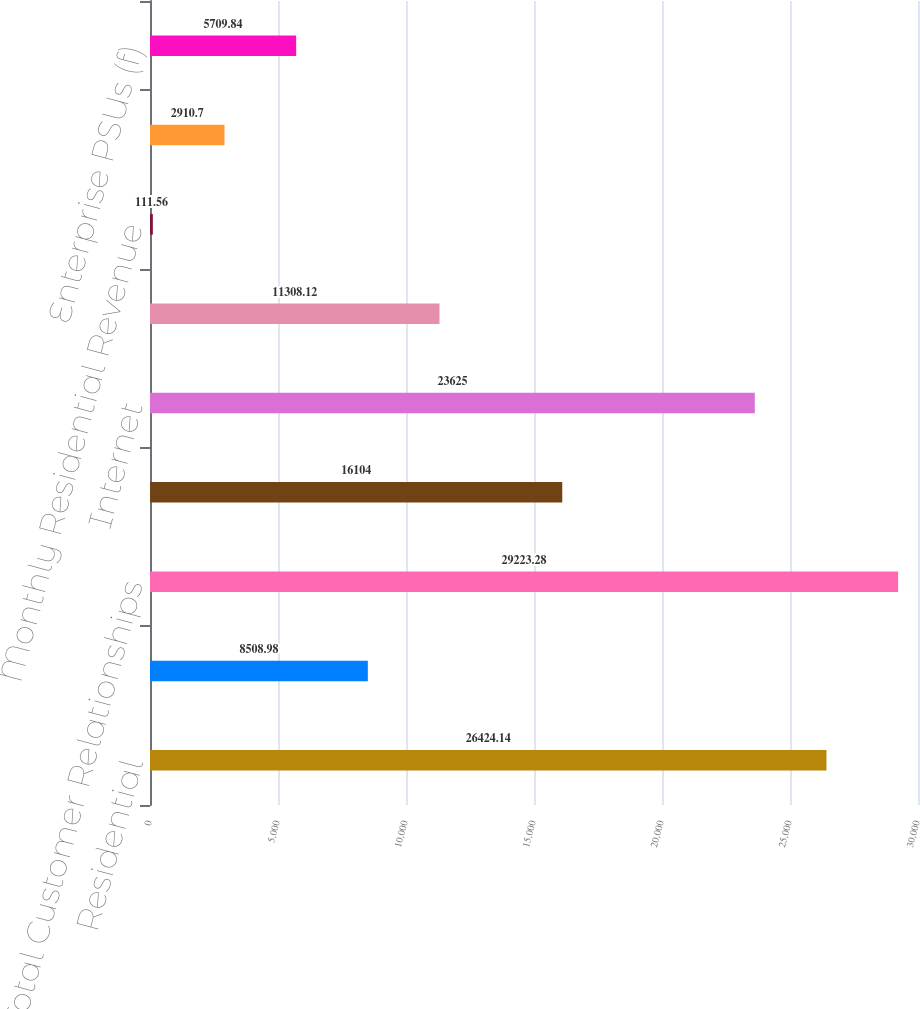Convert chart to OTSL. <chart><loc_0><loc_0><loc_500><loc_500><bar_chart><fcel>Residential<fcel>Small and Medium Business<fcel>Total Customer Relationships<fcel>Video<fcel>Internet<fcel>Voice<fcel>Monthly Residential Revenue<fcel>Monthly Small and Medium<fcel>Enterprise PSUs (f)<nl><fcel>26424.1<fcel>8508.98<fcel>29223.3<fcel>16104<fcel>23625<fcel>11308.1<fcel>111.56<fcel>2910.7<fcel>5709.84<nl></chart> 